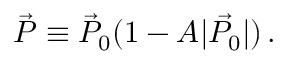<formula> <loc_0><loc_0><loc_500><loc_500>{ \vec { P } } \equiv \vec { P } _ { 0 } ( 1 - A | \vec { P _ { 0 } } | ) \, .</formula> 